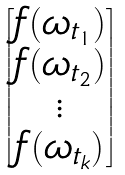Convert formula to latex. <formula><loc_0><loc_0><loc_500><loc_500>\begin{bmatrix} f ( \omega _ { t _ { 1 } } ) \\ f ( \omega _ { t _ { 2 } } ) \\ \vdots \\ f ( \omega _ { t _ { k } } ) \end{bmatrix}</formula> 